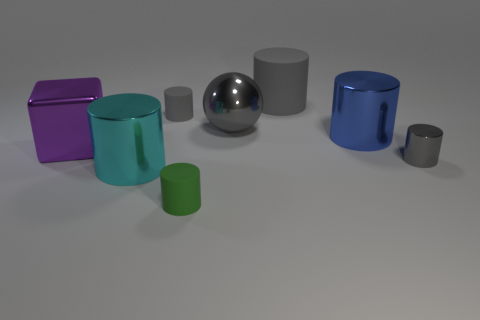There is a shiny cylinder that is the same color as the big matte cylinder; what size is it?
Provide a short and direct response. Small. There is a tiny gray object behind the shiny block; what is its material?
Keep it short and to the point. Rubber. Are there an equal number of tiny gray cylinders that are right of the small gray shiny thing and cyan shiny cylinders behind the large rubber object?
Your answer should be compact. Yes. Does the metal cube left of the small green matte cylinder have the same size as the gray cylinder that is to the left of the green rubber object?
Offer a very short reply. No. What number of big metallic balls are the same color as the tiny metallic thing?
Your answer should be very brief. 1. There is a ball that is the same color as the big matte cylinder; what material is it?
Provide a short and direct response. Metal. Are there more objects in front of the tiny green cylinder than tiny gray matte cylinders?
Give a very brief answer. No. Does the cyan shiny thing have the same shape as the large purple object?
Give a very brief answer. No. What number of tiny purple balls are made of the same material as the big cyan cylinder?
Offer a very short reply. 0. There is a cyan thing that is the same shape as the small green thing; what size is it?
Provide a succinct answer. Large. 